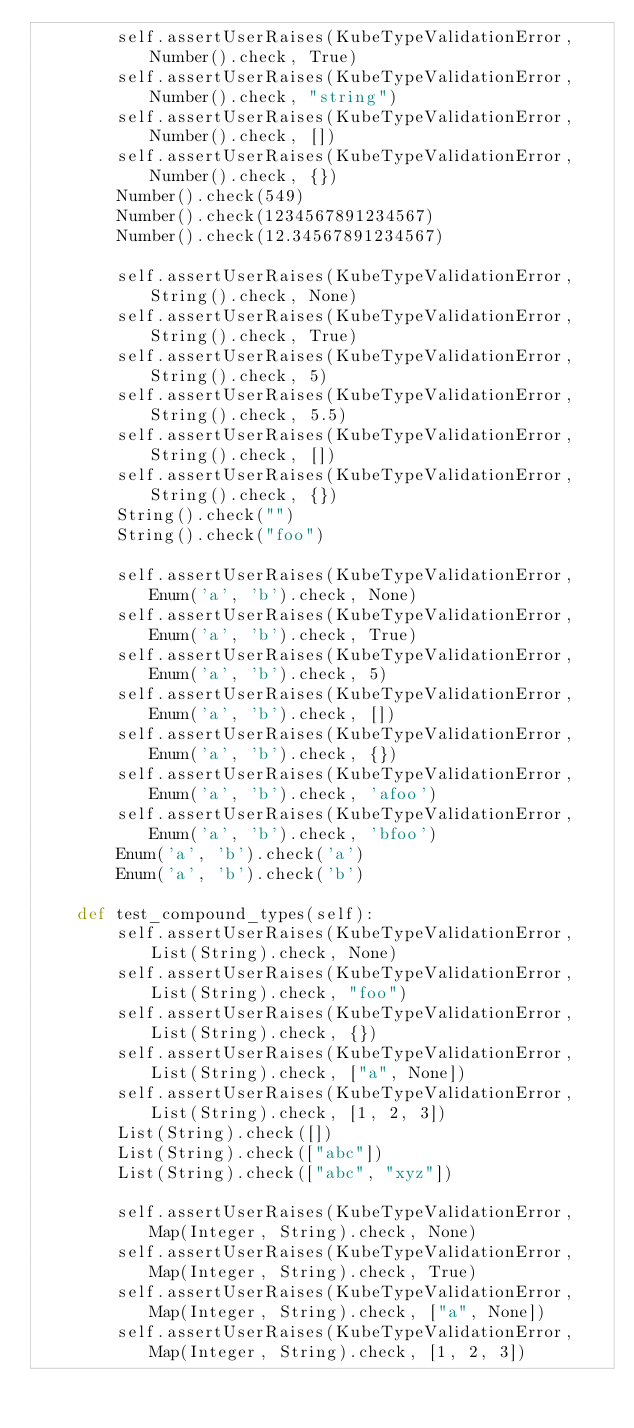<code> <loc_0><loc_0><loc_500><loc_500><_Python_>        self.assertUserRaises(KubeTypeValidationError, Number().check, True)
        self.assertUserRaises(KubeTypeValidationError, Number().check, "string")
        self.assertUserRaises(KubeTypeValidationError, Number().check, [])
        self.assertUserRaises(KubeTypeValidationError, Number().check, {})
        Number().check(549)
        Number().check(1234567891234567)
        Number().check(12.34567891234567)

        self.assertUserRaises(KubeTypeValidationError, String().check, None)
        self.assertUserRaises(KubeTypeValidationError, String().check, True)
        self.assertUserRaises(KubeTypeValidationError, String().check, 5)
        self.assertUserRaises(KubeTypeValidationError, String().check, 5.5)
        self.assertUserRaises(KubeTypeValidationError, String().check, [])
        self.assertUserRaises(KubeTypeValidationError, String().check, {})
        String().check("")
        String().check("foo")

        self.assertUserRaises(KubeTypeValidationError, Enum('a', 'b').check, None)
        self.assertUserRaises(KubeTypeValidationError, Enum('a', 'b').check, True)
        self.assertUserRaises(KubeTypeValidationError, Enum('a', 'b').check, 5)
        self.assertUserRaises(KubeTypeValidationError, Enum('a', 'b').check, [])
        self.assertUserRaises(KubeTypeValidationError, Enum('a', 'b').check, {})
        self.assertUserRaises(KubeTypeValidationError, Enum('a', 'b').check, 'afoo')
        self.assertUserRaises(KubeTypeValidationError, Enum('a', 'b').check, 'bfoo')
        Enum('a', 'b').check('a')
        Enum('a', 'b').check('b')

    def test_compound_types(self):
        self.assertUserRaises(KubeTypeValidationError, List(String).check, None)
        self.assertUserRaises(KubeTypeValidationError, List(String).check, "foo")
        self.assertUserRaises(KubeTypeValidationError, List(String).check, {})
        self.assertUserRaises(KubeTypeValidationError, List(String).check, ["a", None])
        self.assertUserRaises(KubeTypeValidationError, List(String).check, [1, 2, 3])
        List(String).check([])
        List(String).check(["abc"])
        List(String).check(["abc", "xyz"])

        self.assertUserRaises(KubeTypeValidationError, Map(Integer, String).check, None)
        self.assertUserRaises(KubeTypeValidationError, Map(Integer, String).check, True)
        self.assertUserRaises(KubeTypeValidationError, Map(Integer, String).check, ["a", None])
        self.assertUserRaises(KubeTypeValidationError, Map(Integer, String).check, [1, 2, 3])</code> 